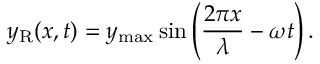Convert formula to latex. <formula><loc_0><loc_0><loc_500><loc_500>y _ { R } ( x , t ) = y _ { \max } \sin \left ( { \frac { 2 \pi x } { \lambda } } - \omega t \right ) .</formula> 